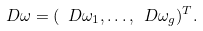Convert formula to latex. <formula><loc_0><loc_0><loc_500><loc_500>\ D \omega = ( \ D \omega _ { 1 } , \dots , \ D \omega _ { g } ) ^ { T } .</formula> 